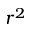Convert formula to latex. <formula><loc_0><loc_0><loc_500><loc_500>r ^ { 2 }</formula> 